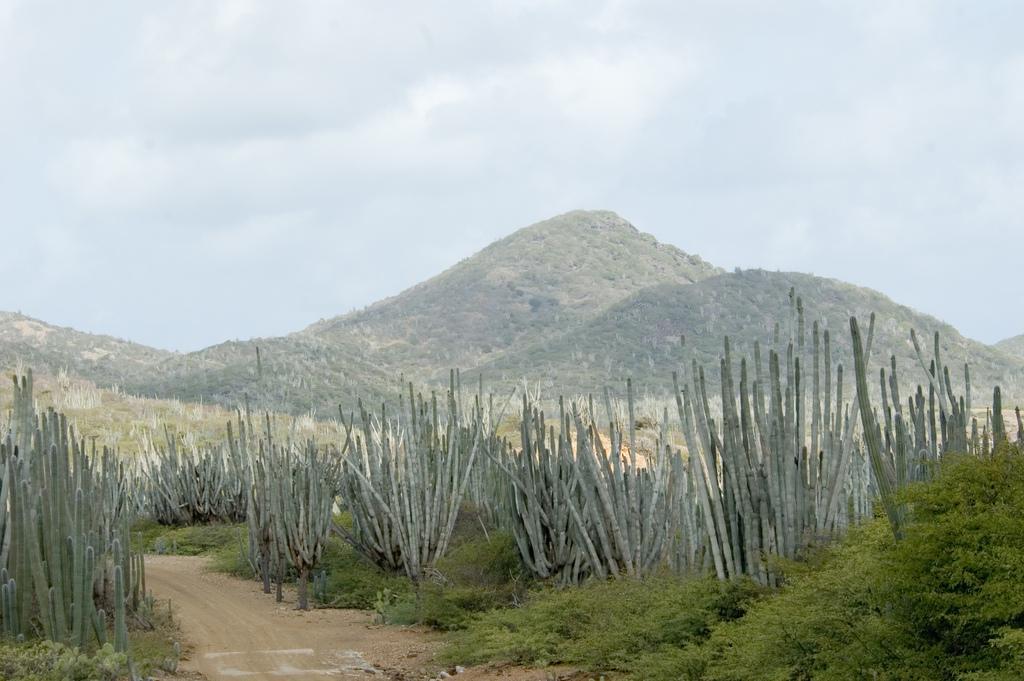Could you give a brief overview of what you see in this image? In this image I can see few plants. In the back there are mountains and the sky. 